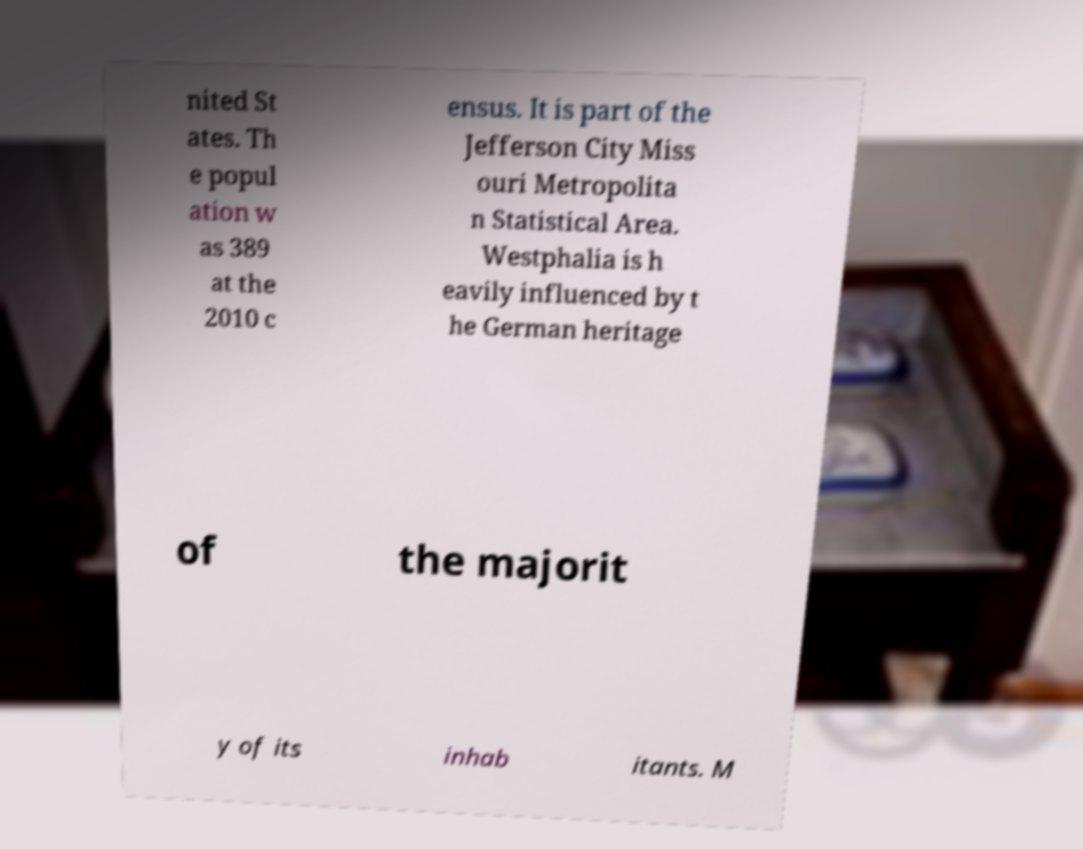Can you accurately transcribe the text from the provided image for me? nited St ates. Th e popul ation w as 389 at the 2010 c ensus. It is part of the Jefferson City Miss ouri Metropolita n Statistical Area. Westphalia is h eavily influenced by t he German heritage of the majorit y of its inhab itants. M 